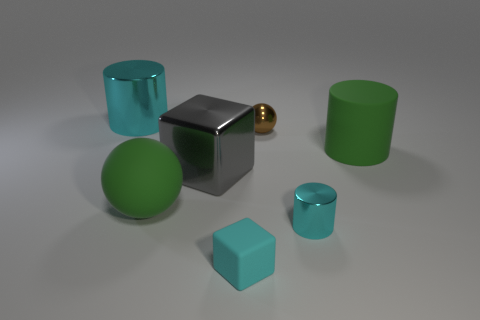What is the material of the cyan thing that is both to the left of the small brown metallic object and in front of the rubber cylinder?
Offer a terse response. Rubber. There is a big cylinder that is made of the same material as the gray thing; what is its color?
Make the answer very short. Cyan. What number of objects are small metal things or large shiny things?
Your answer should be very brief. 4. There is a green rubber cylinder; is it the same size as the ball on the left side of the cyan rubber object?
Your response must be concise. Yes. What color is the cylinder in front of the big green ball in front of the large cylinder that is on the left side of the tiny cylinder?
Keep it short and to the point. Cyan. What is the color of the rubber sphere?
Your answer should be very brief. Green. Is the number of cylinders to the right of the large green ball greater than the number of tiny cyan matte objects on the left side of the tiny brown metallic ball?
Your answer should be compact. Yes. There is a tiny cyan matte thing; does it have the same shape as the big green object on the right side of the small brown ball?
Offer a terse response. No. Is the size of the sphere that is on the right side of the tiny rubber thing the same as the object that is on the left side of the big ball?
Provide a short and direct response. No. Are there any large things that are left of the cyan metal cylinder that is to the right of the metal cylinder that is left of the green matte ball?
Offer a terse response. Yes. 